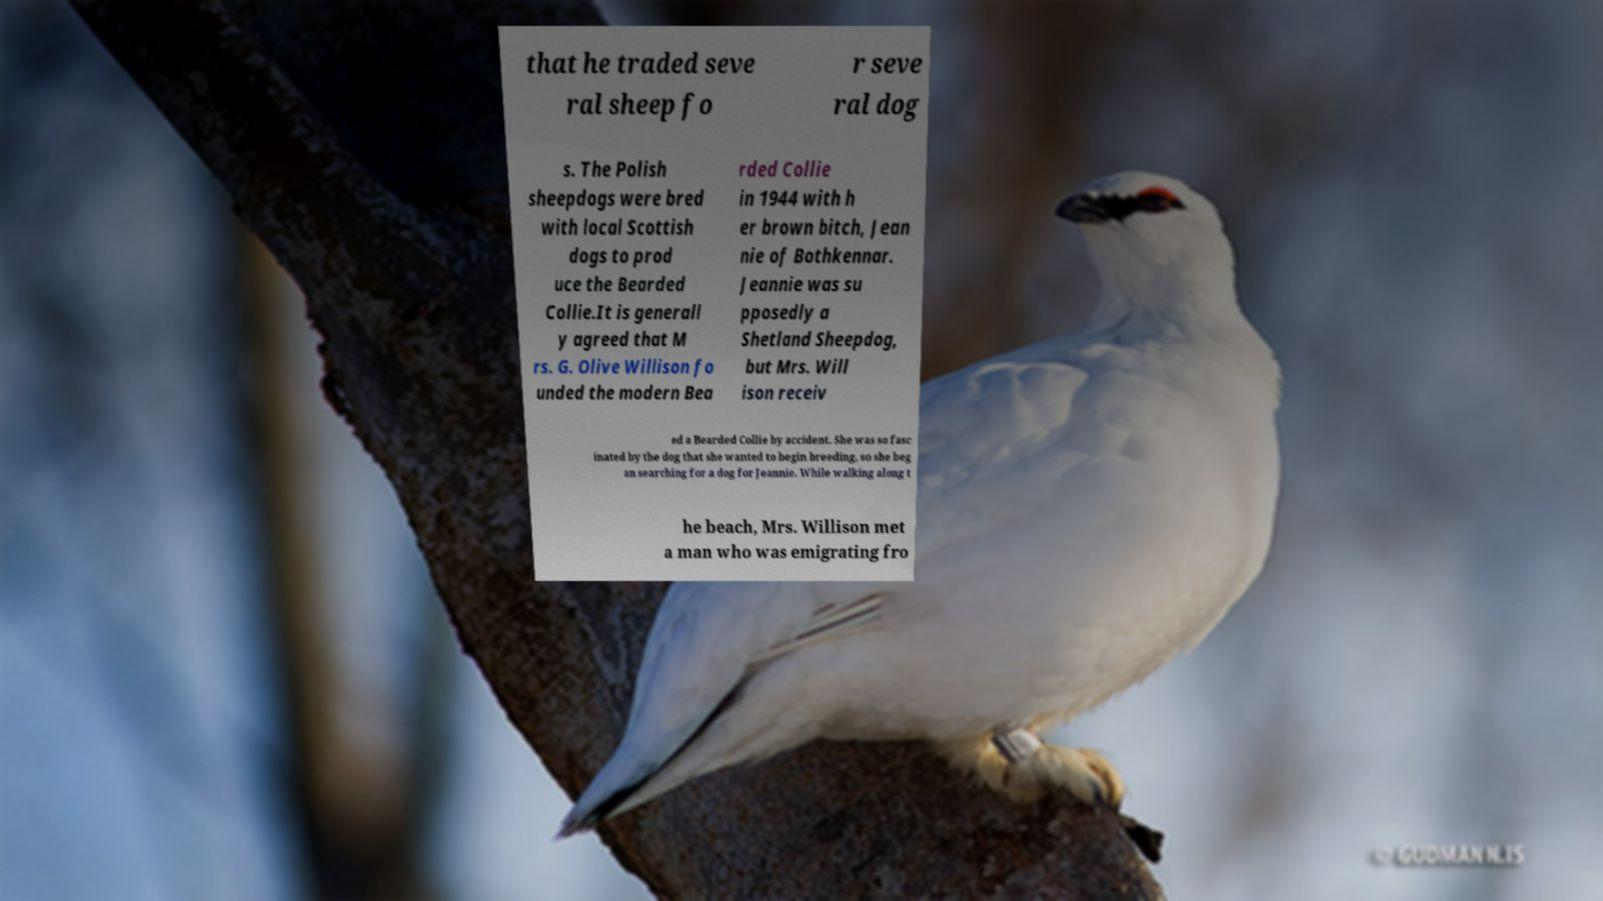Can you accurately transcribe the text from the provided image for me? that he traded seve ral sheep fo r seve ral dog s. The Polish sheepdogs were bred with local Scottish dogs to prod uce the Bearded Collie.It is generall y agreed that M rs. G. Olive Willison fo unded the modern Bea rded Collie in 1944 with h er brown bitch, Jean nie of Bothkennar. Jeannie was su pposedly a Shetland Sheepdog, but Mrs. Will ison receiv ed a Bearded Collie by accident. She was so fasc inated by the dog that she wanted to begin breeding, so she beg an searching for a dog for Jeannie. While walking along t he beach, Mrs. Willison met a man who was emigrating fro 